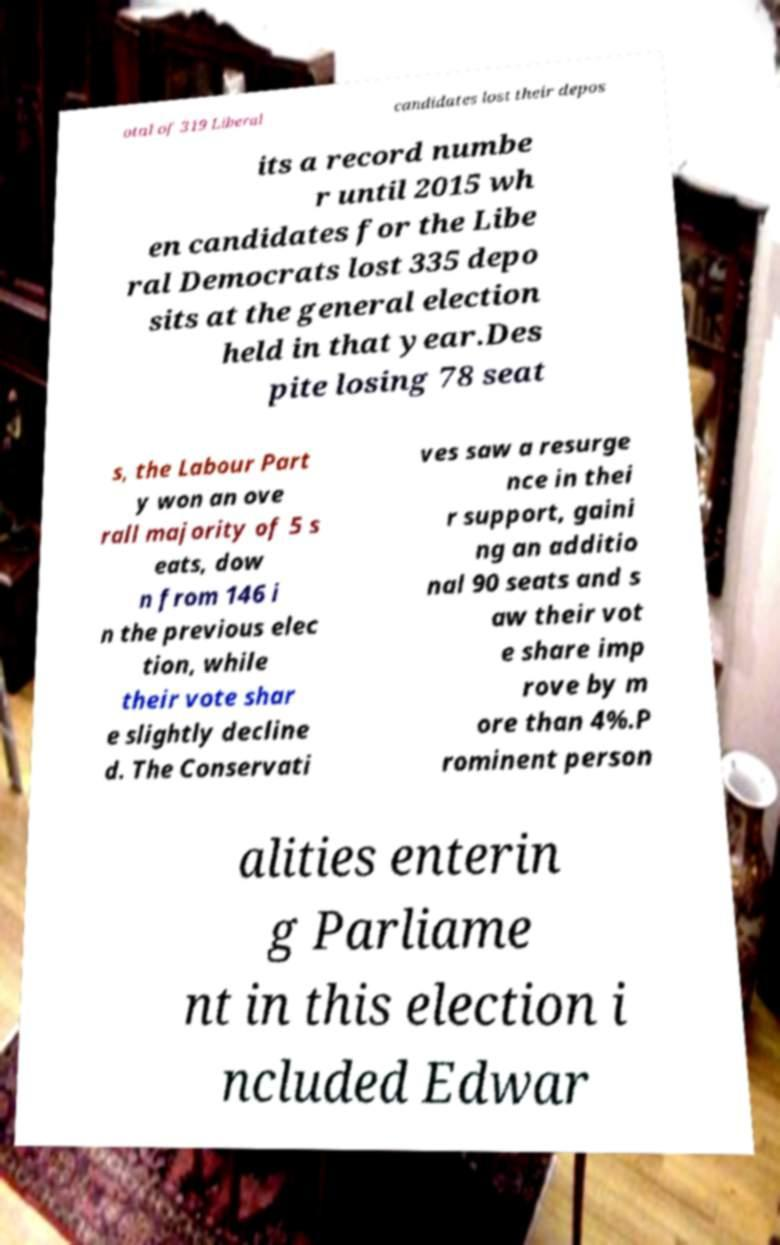Can you read and provide the text displayed in the image?This photo seems to have some interesting text. Can you extract and type it out for me? otal of 319 Liberal candidates lost their depos its a record numbe r until 2015 wh en candidates for the Libe ral Democrats lost 335 depo sits at the general election held in that year.Des pite losing 78 seat s, the Labour Part y won an ove rall majority of 5 s eats, dow n from 146 i n the previous elec tion, while their vote shar e slightly decline d. The Conservati ves saw a resurge nce in thei r support, gaini ng an additio nal 90 seats and s aw their vot e share imp rove by m ore than 4%.P rominent person alities enterin g Parliame nt in this election i ncluded Edwar 